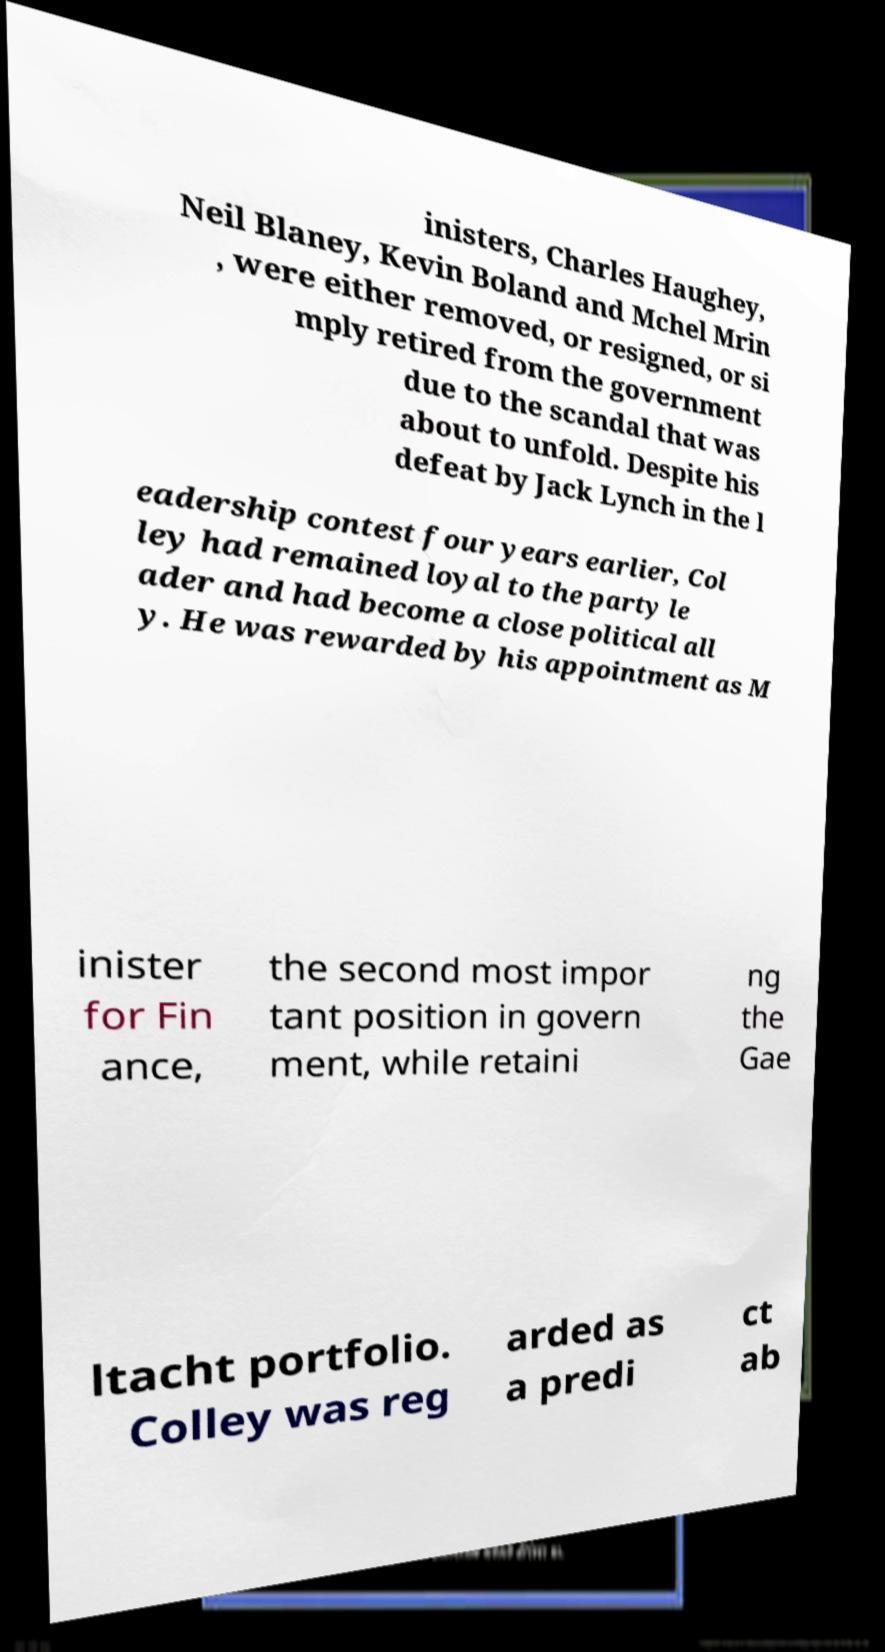Can you accurately transcribe the text from the provided image for me? inisters, Charles Haughey, Neil Blaney, Kevin Boland and Mchel Mrin , were either removed, or resigned, or si mply retired from the government due to the scandal that was about to unfold. Despite his defeat by Jack Lynch in the l eadership contest four years earlier, Col ley had remained loyal to the party le ader and had become a close political all y. He was rewarded by his appointment as M inister for Fin ance, the second most impor tant position in govern ment, while retaini ng the Gae ltacht portfolio. Colley was reg arded as a predi ct ab 